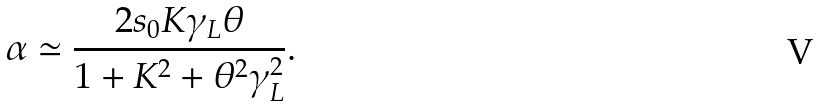<formula> <loc_0><loc_0><loc_500><loc_500>\alpha \simeq \frac { 2 s _ { 0 } K \gamma _ { L } \theta } { 1 + K ^ { 2 } + \theta ^ { 2 } \gamma _ { L } ^ { 2 } } .</formula> 